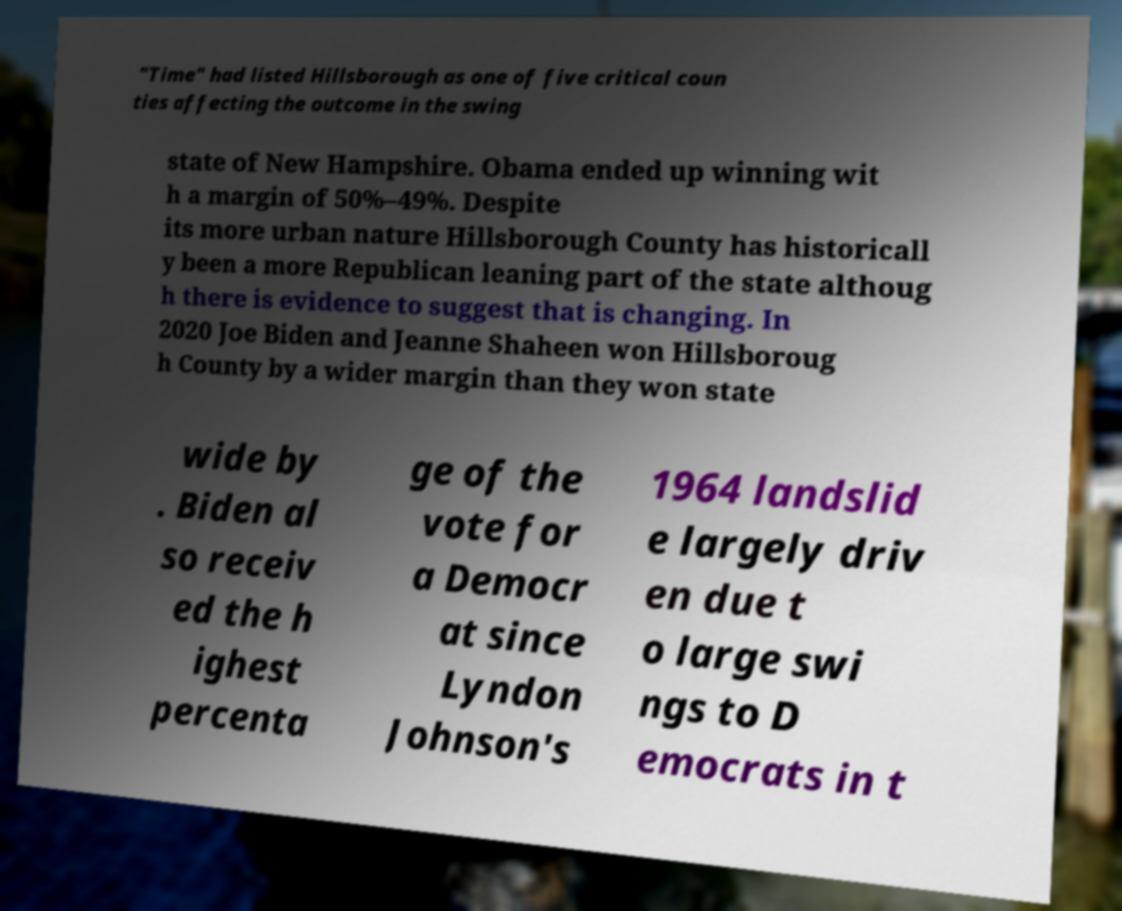Can you read and provide the text displayed in the image?This photo seems to have some interesting text. Can you extract and type it out for me? "Time" had listed Hillsborough as one of five critical coun ties affecting the outcome in the swing state of New Hampshire. Obama ended up winning wit h a margin of 50%–49%. Despite its more urban nature Hillsborough County has historicall y been a more Republican leaning part of the state althoug h there is evidence to suggest that is changing. In 2020 Joe Biden and Jeanne Shaheen won Hillsboroug h County by a wider margin than they won state wide by . Biden al so receiv ed the h ighest percenta ge of the vote for a Democr at since Lyndon Johnson's 1964 landslid e largely driv en due t o large swi ngs to D emocrats in t 